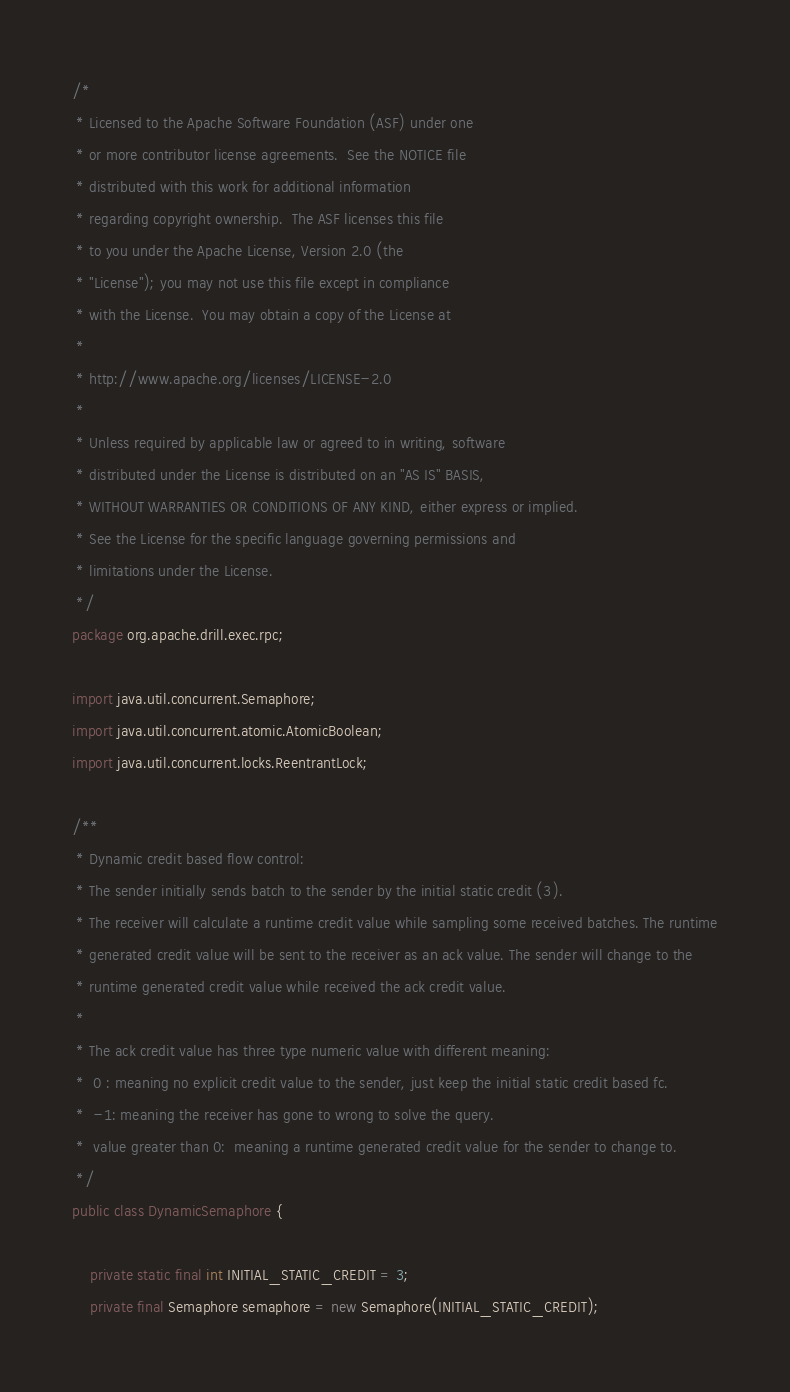Convert code to text. <code><loc_0><loc_0><loc_500><loc_500><_Java_>/*
 * Licensed to the Apache Software Foundation (ASF) under one
 * or more contributor license agreements.  See the NOTICE file
 * distributed with this work for additional information
 * regarding copyright ownership.  The ASF licenses this file
 * to you under the Apache License, Version 2.0 (the
 * "License"); you may not use this file except in compliance
 * with the License.  You may obtain a copy of the License at
 *
 * http://www.apache.org/licenses/LICENSE-2.0
 *
 * Unless required by applicable law or agreed to in writing, software
 * distributed under the License is distributed on an "AS IS" BASIS,
 * WITHOUT WARRANTIES OR CONDITIONS OF ANY KIND, either express or implied.
 * See the License for the specific language governing permissions and
 * limitations under the License.
 */
package org.apache.drill.exec.rpc;

import java.util.concurrent.Semaphore;
import java.util.concurrent.atomic.AtomicBoolean;
import java.util.concurrent.locks.ReentrantLock;

/**
 * Dynamic credit based flow control:
 * The sender initially sends batch to the sender by the initial static credit (3).
 * The receiver will calculate a runtime credit value while sampling some received batches. The runtime
 * generated credit value will be sent to the receiver as an ack value. The sender will change to the
 * runtime generated credit value while received the ack credit value.
 *
 * The ack credit value has three type numeric value with different meaning:
 *  0 : meaning no explicit credit value to the sender, just keep the initial static credit based fc.
 *  -1: meaning the receiver has gone to wrong to solve the query.
 *  value greater than 0:  meaning a runtime generated credit value for the sender to change to.
 */
public class DynamicSemaphore {

    private static final int INITIAL_STATIC_CREDIT = 3;
    private final Semaphore semaphore = new Semaphore(INITIAL_STATIC_CREDIT);</code> 